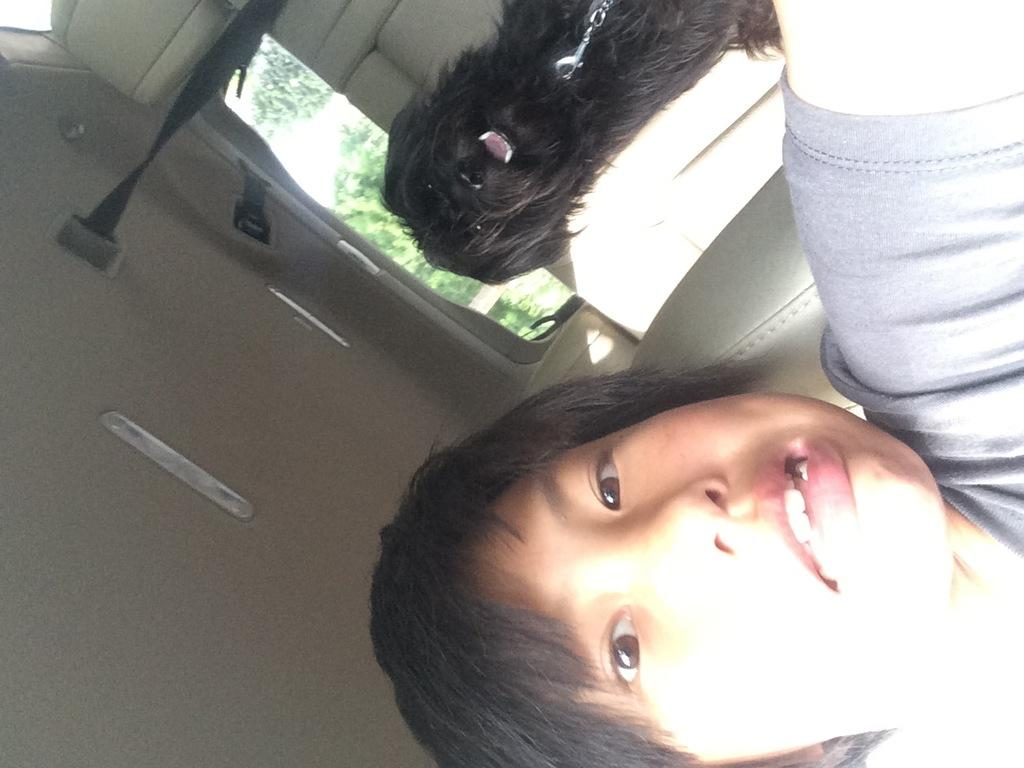Who is the main subject in the front of the image? There is a boy in the front of the image. What can be seen in the background of the image? There is a dog and trees in the background of the image. Can you describe the dog in the image? The dog is black in color. What accessory is visible in the image? There is a belt visible in the image. How many sisters does the boy have in the image? There is no mention of sisters in the image, so we cannot determine the number of sisters the boy has. 